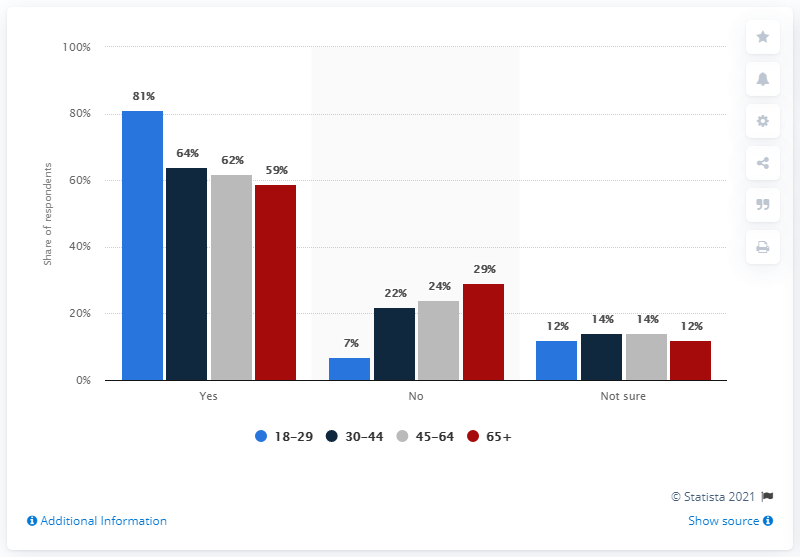Which age group seems the least sure about their response? The age group that indicates the highest level of uncertainty is the 65 and above category. This is shown by the dark red bar under 'Not sure' being the highest among all age groups, at 14%. 